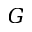Convert formula to latex. <formula><loc_0><loc_0><loc_500><loc_500>G</formula> 